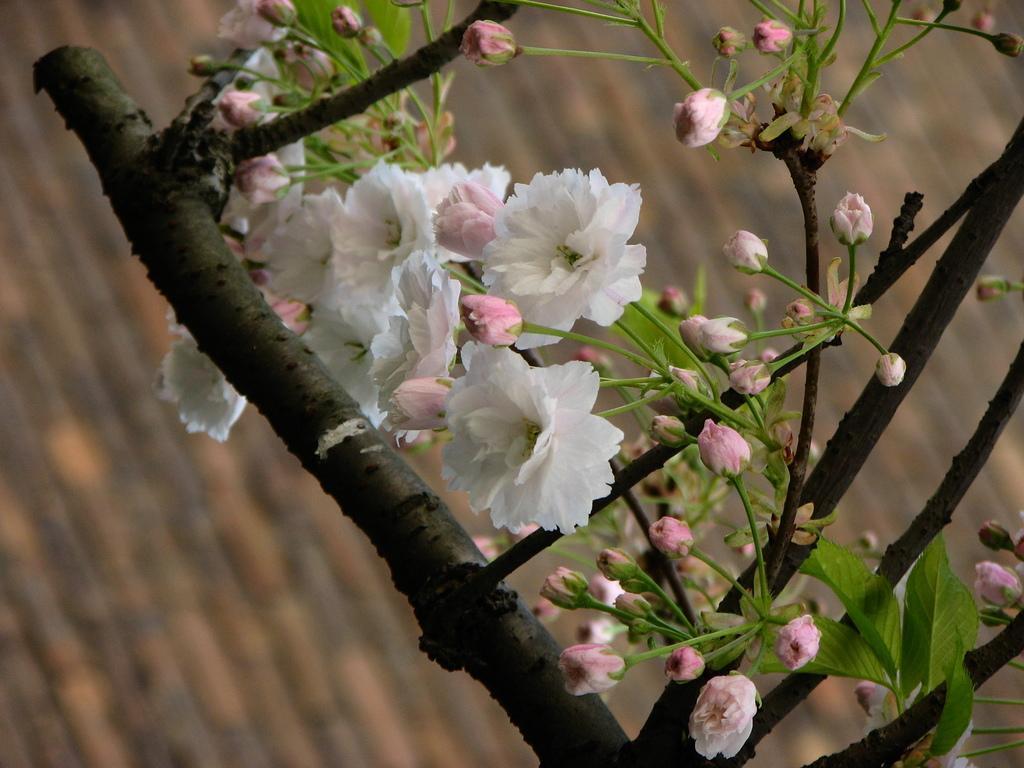Could you give a brief overview of what you see in this image? In this image I can see few flowers which are white, green and pink in color to a plant which is green and brown in color. I can see the blurry background which is brown and black in color. 